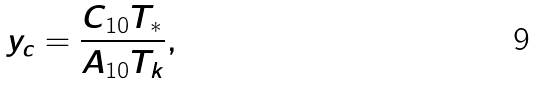<formula> <loc_0><loc_0><loc_500><loc_500>y _ { c } = \frac { C _ { 1 0 } T _ { \ast } } { A _ { 1 0 } T _ { k } } ,</formula> 